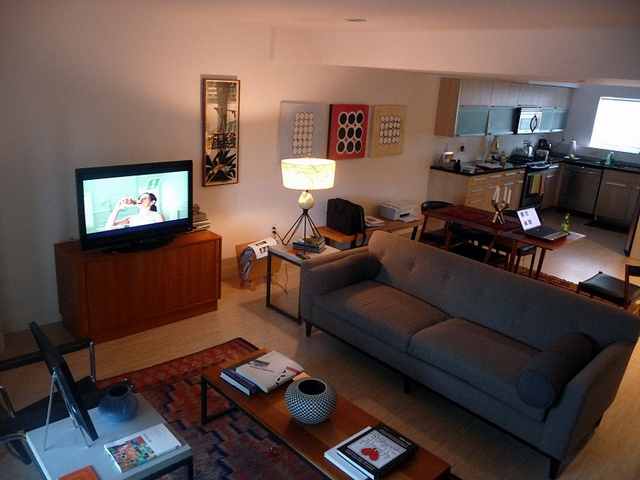Describe the objects in this image and their specific colors. I can see couch in brown, black, and maroon tones, tv in brown, white, black, turquoise, and navy tones, dining table in brown, black, maroon, and gray tones, book in brown, black, darkgray, and gray tones, and book in brown, lightblue, gray, and darkgray tones in this image. 